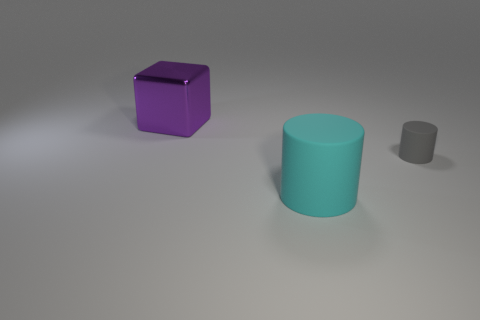Add 3 tiny matte cylinders. How many objects exist? 6 Subtract all blocks. How many objects are left? 2 Add 3 small gray cylinders. How many small gray cylinders are left? 4 Add 2 large blue cubes. How many large blue cubes exist? 2 Subtract 0 red spheres. How many objects are left? 3 Subtract all big purple metal blocks. Subtract all matte cylinders. How many objects are left? 0 